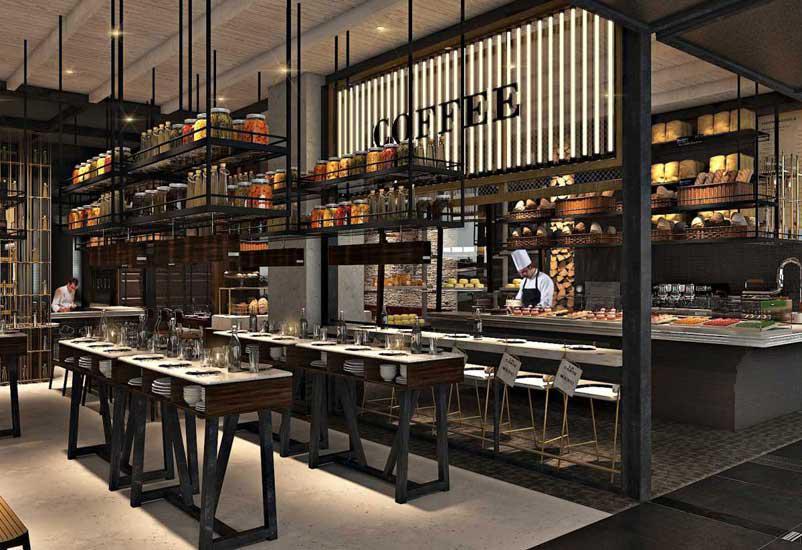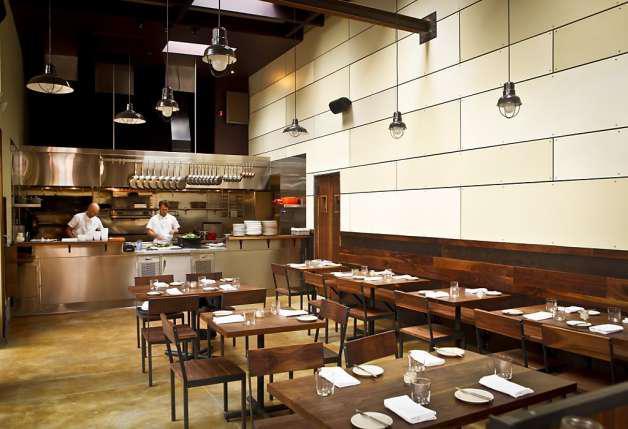The first image is the image on the left, the second image is the image on the right. Assess this claim about the two images: "Each image contains restaurant employees". Correct or not? Answer yes or no. Yes. The first image is the image on the left, the second image is the image on the right. For the images shown, is this caption "People in white shirts are in front of and behind the long counter of an establishment with suspended glass lights in one image." true? Answer yes or no. No. 